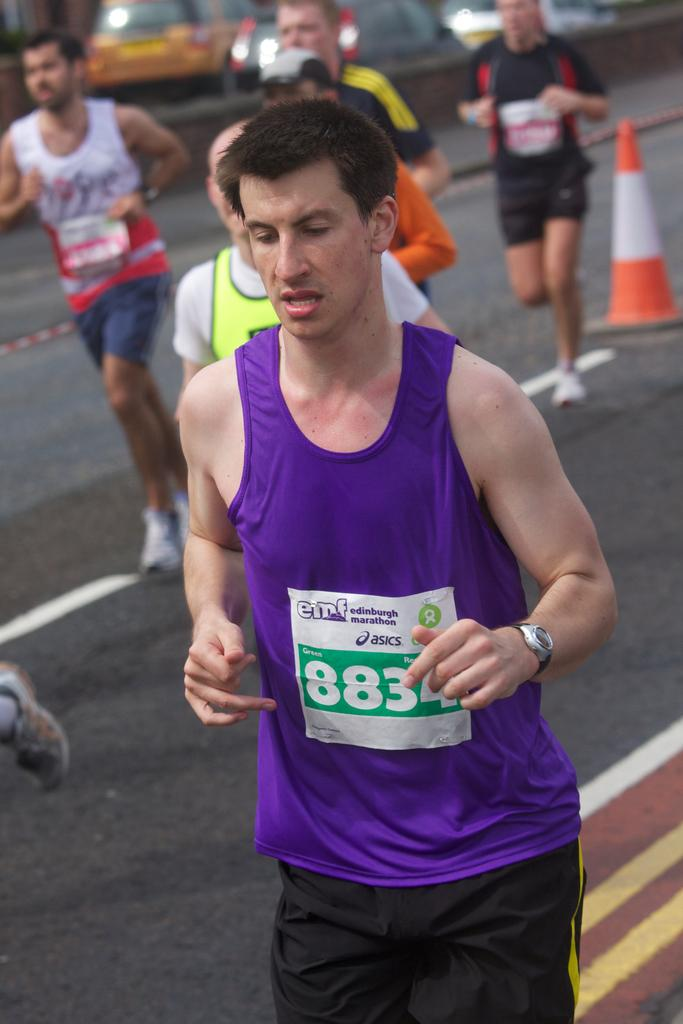What are the persons in the image doing? The persons in the image are running. What can be seen in the background of the image? There are cars in the background of the image. What is the color and pattern of the stand in the image? The stand in the image is red and white. What type of structure is present in the image? There is a wall in the image. What type of stick is being used by the bear in the image? There is no bear present in the image, and therefore no stick being used. 